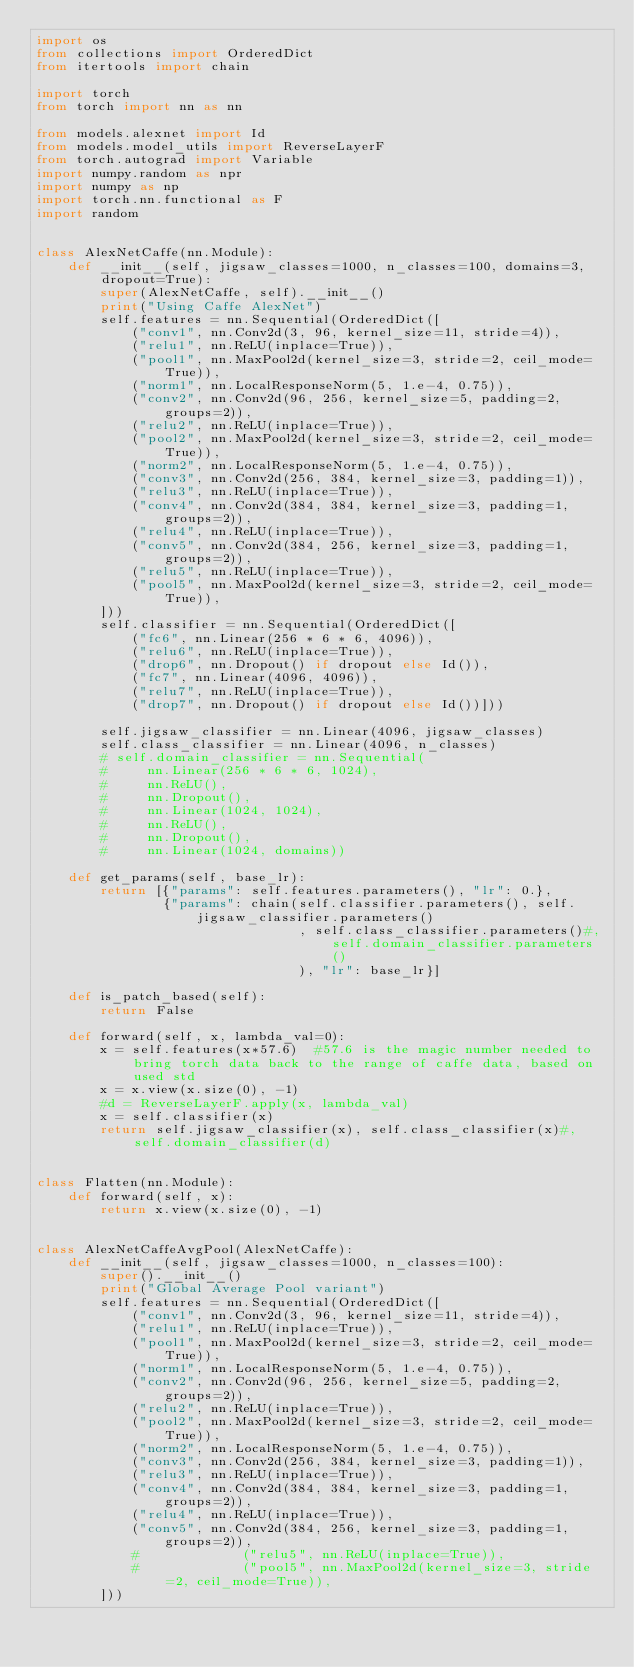<code> <loc_0><loc_0><loc_500><loc_500><_Python_>import os
from collections import OrderedDict
from itertools import chain

import torch
from torch import nn as nn

from models.alexnet import Id
from models.model_utils import ReverseLayerF
from torch.autograd import Variable
import numpy.random as npr
import numpy as np
import torch.nn.functional as F
import random


class AlexNetCaffe(nn.Module):
    def __init__(self, jigsaw_classes=1000, n_classes=100, domains=3, dropout=True):
        super(AlexNetCaffe, self).__init__()
        print("Using Caffe AlexNet")
        self.features = nn.Sequential(OrderedDict([
            ("conv1", nn.Conv2d(3, 96, kernel_size=11, stride=4)),
            ("relu1", nn.ReLU(inplace=True)),
            ("pool1", nn.MaxPool2d(kernel_size=3, stride=2, ceil_mode=True)),
            ("norm1", nn.LocalResponseNorm(5, 1.e-4, 0.75)),
            ("conv2", nn.Conv2d(96, 256, kernel_size=5, padding=2, groups=2)),
            ("relu2", nn.ReLU(inplace=True)),
            ("pool2", nn.MaxPool2d(kernel_size=3, stride=2, ceil_mode=True)),
            ("norm2", nn.LocalResponseNorm(5, 1.e-4, 0.75)),
            ("conv3", nn.Conv2d(256, 384, kernel_size=3, padding=1)),
            ("relu3", nn.ReLU(inplace=True)),
            ("conv4", nn.Conv2d(384, 384, kernel_size=3, padding=1, groups=2)),
            ("relu4", nn.ReLU(inplace=True)),
            ("conv5", nn.Conv2d(384, 256, kernel_size=3, padding=1, groups=2)),
            ("relu5", nn.ReLU(inplace=True)),
            ("pool5", nn.MaxPool2d(kernel_size=3, stride=2, ceil_mode=True)),
        ]))
        self.classifier = nn.Sequential(OrderedDict([
            ("fc6", nn.Linear(256 * 6 * 6, 4096)),
            ("relu6", nn.ReLU(inplace=True)),
            ("drop6", nn.Dropout() if dropout else Id()),
            ("fc7", nn.Linear(4096, 4096)),
            ("relu7", nn.ReLU(inplace=True)),
            ("drop7", nn.Dropout() if dropout else Id())]))

        self.jigsaw_classifier = nn.Linear(4096, jigsaw_classes)
        self.class_classifier = nn.Linear(4096, n_classes)
        # self.domain_classifier = nn.Sequential(
        #     nn.Linear(256 * 6 * 6, 1024),
        #     nn.ReLU(),
        #     nn.Dropout(),
        #     nn.Linear(1024, 1024),
        #     nn.ReLU(),
        #     nn.Dropout(),
        #     nn.Linear(1024, domains))

    def get_params(self, base_lr):
        return [{"params": self.features.parameters(), "lr": 0.},
                {"params": chain(self.classifier.parameters(), self.jigsaw_classifier.parameters()
                                 , self.class_classifier.parameters()#, self.domain_classifier.parameters()
                                 ), "lr": base_lr}]

    def is_patch_based(self):
        return False

    def forward(self, x, lambda_val=0):
        x = self.features(x*57.6)  #57.6 is the magic number needed to bring torch data back to the range of caffe data, based on used std
        x = x.view(x.size(0), -1)
        #d = ReverseLayerF.apply(x, lambda_val)
        x = self.classifier(x)
        return self.jigsaw_classifier(x), self.class_classifier(x)#, self.domain_classifier(d)


class Flatten(nn.Module):
    def forward(self, x):
        return x.view(x.size(0), -1)


class AlexNetCaffeAvgPool(AlexNetCaffe):
    def __init__(self, jigsaw_classes=1000, n_classes=100):
        super().__init__()
        print("Global Average Pool variant")
        self.features = nn.Sequential(OrderedDict([
            ("conv1", nn.Conv2d(3, 96, kernel_size=11, stride=4)),
            ("relu1", nn.ReLU(inplace=True)),
            ("pool1", nn.MaxPool2d(kernel_size=3, stride=2, ceil_mode=True)),
            ("norm1", nn.LocalResponseNorm(5, 1.e-4, 0.75)),
            ("conv2", nn.Conv2d(96, 256, kernel_size=5, padding=2, groups=2)),
            ("relu2", nn.ReLU(inplace=True)),
            ("pool2", nn.MaxPool2d(kernel_size=3, stride=2, ceil_mode=True)),
            ("norm2", nn.LocalResponseNorm(5, 1.e-4, 0.75)),
            ("conv3", nn.Conv2d(256, 384, kernel_size=3, padding=1)),
            ("relu3", nn.ReLU(inplace=True)),
            ("conv4", nn.Conv2d(384, 384, kernel_size=3, padding=1, groups=2)),
            ("relu4", nn.ReLU(inplace=True)),
            ("conv5", nn.Conv2d(384, 256, kernel_size=3, padding=1, groups=2)),
            #             ("relu5", nn.ReLU(inplace=True)),
            #             ("pool5", nn.MaxPool2d(kernel_size=3, stride=2, ceil_mode=True)),
        ]))</code> 